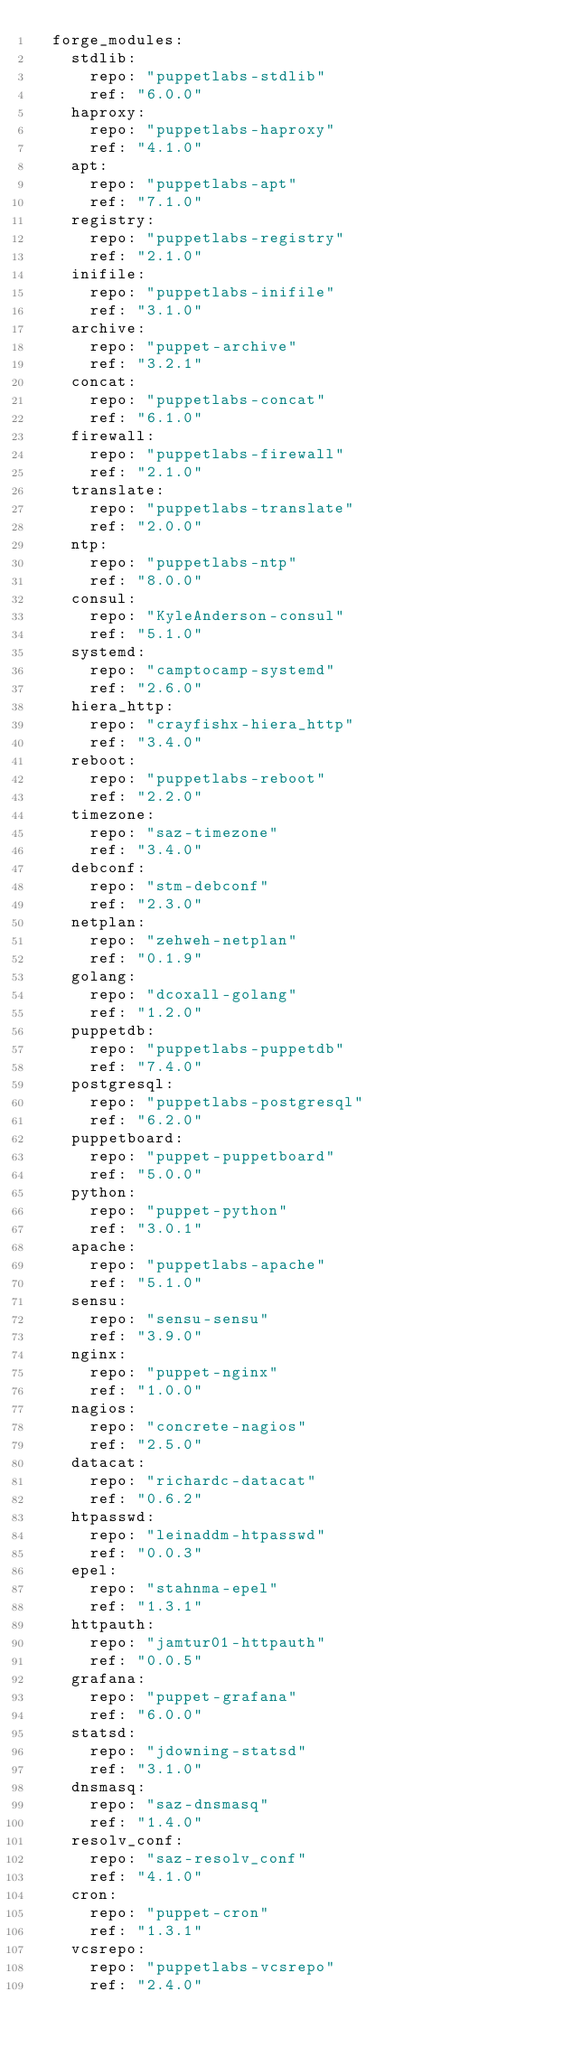<code> <loc_0><loc_0><loc_500><loc_500><_YAML_>  forge_modules:
    stdlib:
      repo: "puppetlabs-stdlib"
      ref: "6.0.0"
    haproxy:
      repo: "puppetlabs-haproxy"
      ref: "4.1.0"
    apt:
      repo: "puppetlabs-apt"
      ref: "7.1.0"
    registry:
      repo: "puppetlabs-registry"
      ref: "2.1.0"
    inifile:
      repo: "puppetlabs-inifile"
      ref: "3.1.0"
    archive:
      repo: "puppet-archive"
      ref: "3.2.1"
    concat:
      repo: "puppetlabs-concat"
      ref: "6.1.0"
    firewall:
      repo: "puppetlabs-firewall"
      ref: "2.1.0"
    translate:
      repo: "puppetlabs-translate"
      ref: "2.0.0"
    ntp:
      repo: "puppetlabs-ntp"
      ref: "8.0.0"
    consul:
      repo: "KyleAnderson-consul"
      ref: "5.1.0"
    systemd:
      repo: "camptocamp-systemd"
      ref: "2.6.0"
    hiera_http:
      repo: "crayfishx-hiera_http"
      ref: "3.4.0"
    reboot:
      repo: "puppetlabs-reboot"
      ref: "2.2.0"
    timezone:
      repo: "saz-timezone"
      ref: "3.4.0"
    debconf:
      repo: "stm-debconf"
      ref: "2.3.0"
    netplan:
      repo: "zehweh-netplan"
      ref: "0.1.9"
    golang:
      repo: "dcoxall-golang"
      ref: "1.2.0"
    puppetdb:
      repo: "puppetlabs-puppetdb"
      ref: "7.4.0"
    postgresql:
      repo: "puppetlabs-postgresql"
      ref: "6.2.0"
    puppetboard:
      repo: "puppet-puppetboard"
      ref: "5.0.0"
    python:
      repo: "puppet-python"
      ref: "3.0.1"
    apache:
      repo: "puppetlabs-apache"
      ref: "5.1.0"
    sensu:
      repo: "sensu-sensu"
      ref: "3.9.0"
    nginx:
      repo: "puppet-nginx"
      ref: "1.0.0"
    nagios:
      repo: "concrete-nagios"
      ref: "2.5.0"
    datacat:
      repo: "richardc-datacat"
      ref: "0.6.2"
    htpasswd:
      repo: "leinaddm-htpasswd"
      ref: "0.0.3"
    epel:
      repo: "stahnma-epel"
      ref: "1.3.1"
    httpauth:
      repo: "jamtur01-httpauth"
      ref: "0.0.5"
    grafana:
      repo: "puppet-grafana"
      ref: "6.0.0"
    statsd:
      repo: "jdowning-statsd"
      ref: "3.1.0"
    dnsmasq:
      repo: "saz-dnsmasq"
      ref: "1.4.0"
    resolv_conf:
      repo: "saz-resolv_conf"
      ref: "4.1.0"
    cron:
      repo: "puppet-cron"
      ref: "1.3.1"
    vcsrepo:
      repo: "puppetlabs-vcsrepo"
      ref: "2.4.0"

</code> 